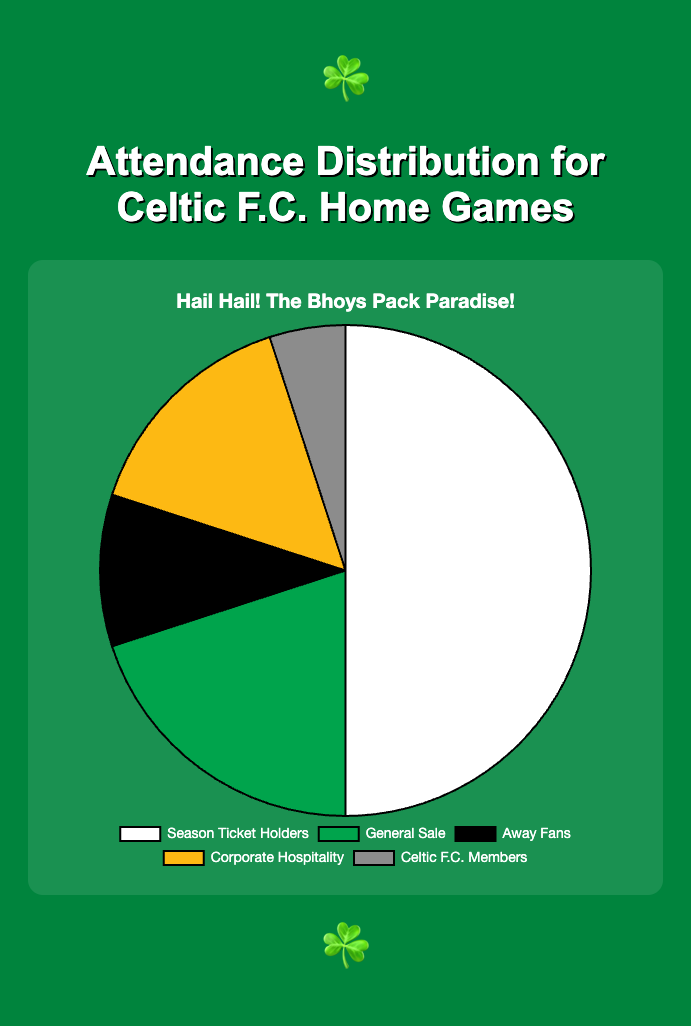Which group has the highest percentage in the attendance distribution? The category with the highest percentage can be identified by looking at the largest segment of the pie chart, which corresponds to the "Season Ticket Holders" with 50%.
Answer: Season Ticket Holders What is the combined percentage of General Sale and Away Fans? To find the combined percentage of General Sale and Away Fans, sum their individual percentages: 20% (General Sale) + 10% (Away Fans) = 30%.
Answer: 30% How much larger is the percentage of Season Ticket Holders compared to Corporate Hospitality? Subtract the percentage of Corporate Hospitality (15%) from that of Season Ticket Holders (50%): 50% - 15% = 35%.
Answer: 35% Which category has the smallest percentage in the attendance distribution? The smallest segment of the pie chart represents the category with the lowest percentage, which is "Celtic F.C. Members" at 5%.
Answer: Celtic F.C. Members What percentage of the attendees are either Season Ticket Holders or Celtic F.C. Members? Add the percentage of Season Ticket Holders (50%) and Celtic F.C. Members (5%): 50% + 5% = 55%.
Answer: 55% How does the percentage of Corporate Hospitality compare to General Sale? Compare the two percentages: Corporate Hospitality has 15% while General Sale has 20%. Corporate Hospitality is 5% less.
Answer: 5% less What’s the difference in attendance percentage between Away Fans and Celtic F.C. Members? Subtract Celtic F.C. Members' percentage (5%) from Away Fans' percentage (10%): 10% - 5% = 5%.
Answer: 5% Out of the total attendees, what fraction are from the General Sale category? The General Sale category accounts for 20% of the attendees. This is equivalent to 20/100 or 1/5 of the total attendees.
Answer: 1/5 What is the total percentage of home team fans including both Season Ticket Holders and Celtic F.C. Members? Add the percentages of Season Ticket Holders (50%) and Celtic F.C. Members (5%): 50% + 5% = 55%.
Answer: 55% What is the sum of the percentages of the three smallest categories? Add the percentages of General Sale (20%), Away Fans (10%), and Celtic F.C. Members (5%): 20% + 10% + 5% = 35%.
Answer: 35% 